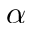Convert formula to latex. <formula><loc_0><loc_0><loc_500><loc_500>\alpha</formula> 